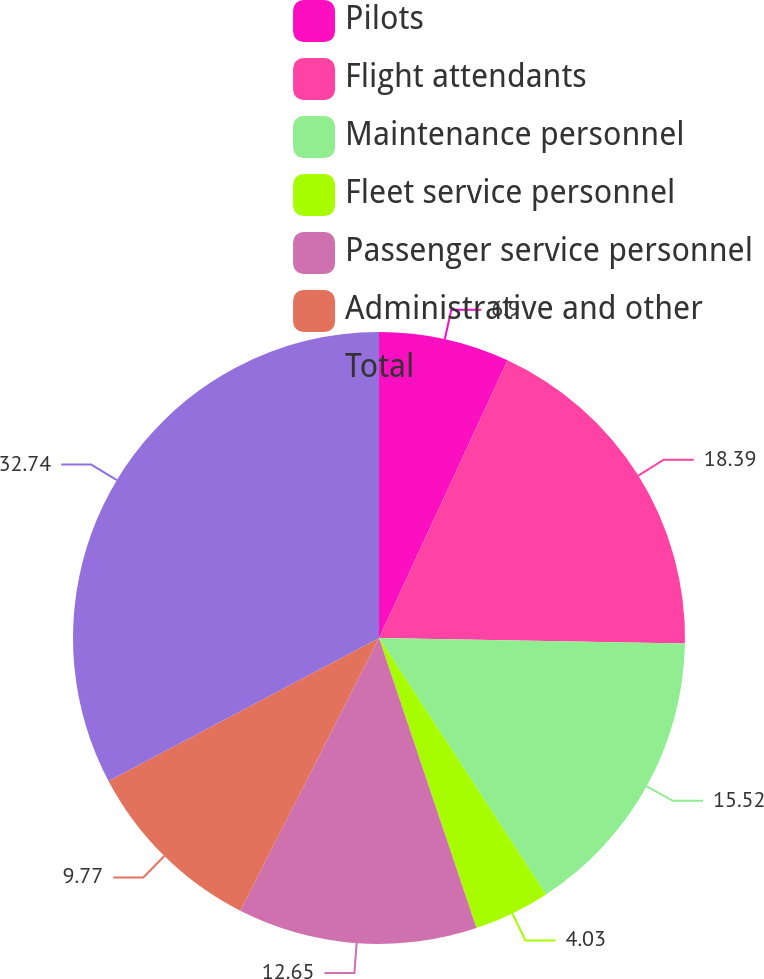Convert chart. <chart><loc_0><loc_0><loc_500><loc_500><pie_chart><fcel>Pilots<fcel>Flight attendants<fcel>Maintenance personnel<fcel>Fleet service personnel<fcel>Passenger service personnel<fcel>Administrative and other<fcel>Total<nl><fcel>6.9%<fcel>18.39%<fcel>15.52%<fcel>4.03%<fcel>12.65%<fcel>9.77%<fcel>32.74%<nl></chart> 